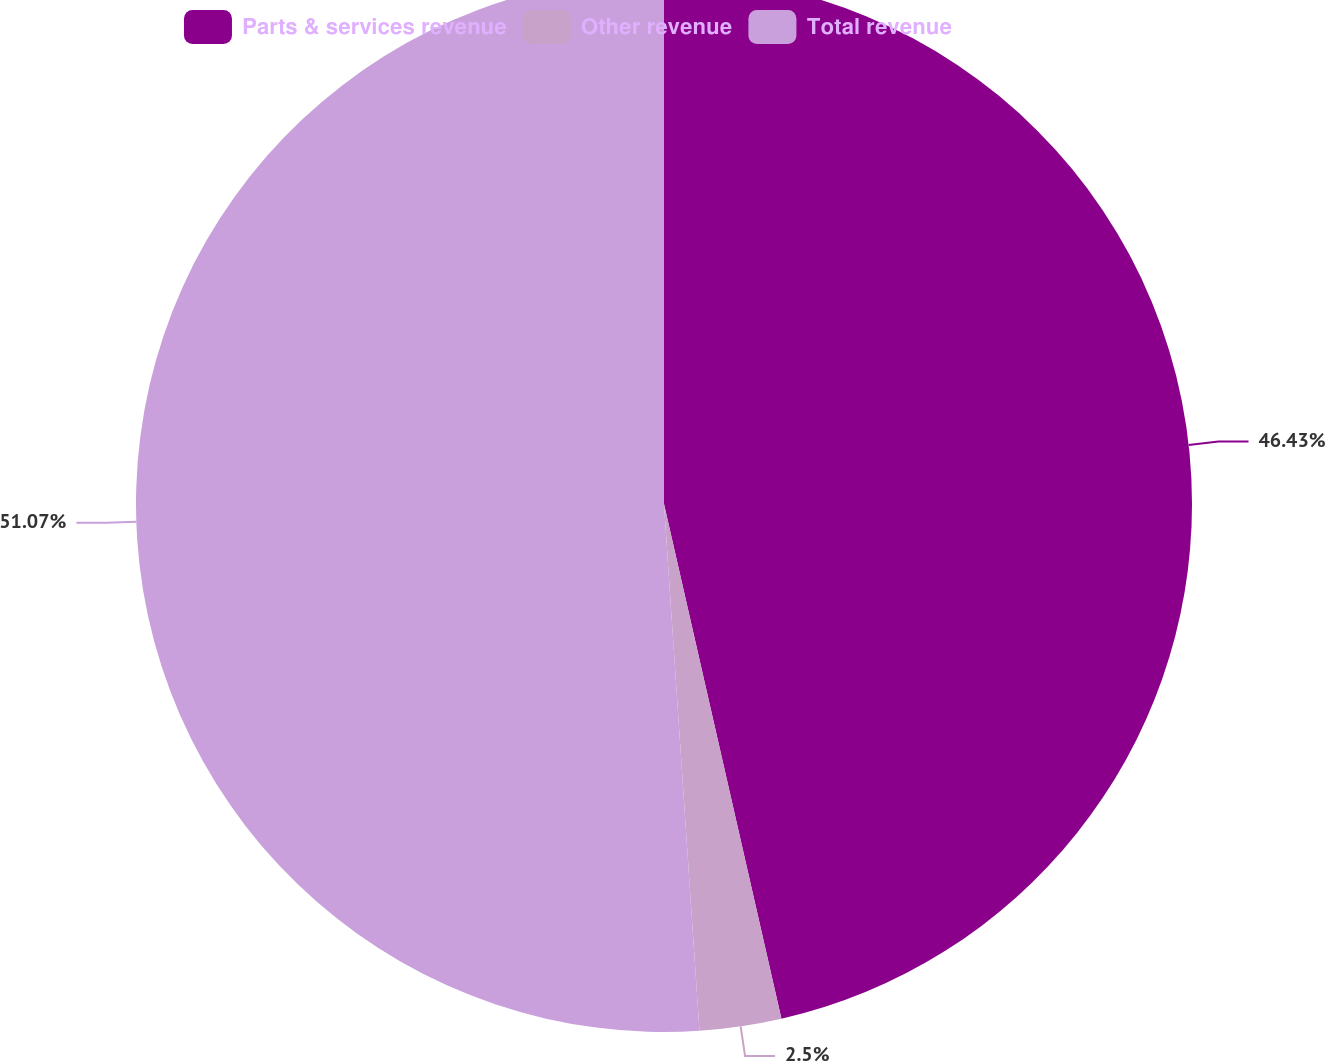Convert chart to OTSL. <chart><loc_0><loc_0><loc_500><loc_500><pie_chart><fcel>Parts & services revenue<fcel>Other revenue<fcel>Total revenue<nl><fcel>46.43%<fcel>2.5%<fcel>51.07%<nl></chart> 